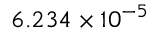Convert formula to latex. <formula><loc_0><loc_0><loc_500><loc_500>6 . 2 3 4 \times 1 0 ^ { - 5 }</formula> 